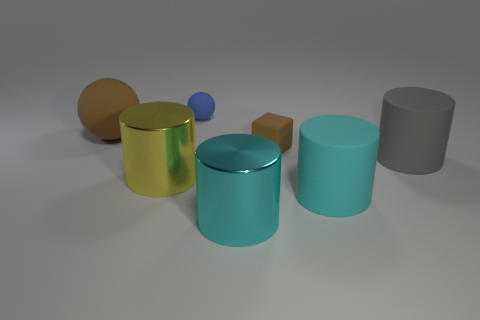Add 1 big yellow rubber objects. How many objects exist? 8 Subtract all cubes. How many objects are left? 6 Add 7 big yellow spheres. How many big yellow spheres exist? 7 Subtract 1 cyan cylinders. How many objects are left? 6 Subtract all blue matte balls. Subtract all large brown things. How many objects are left? 5 Add 2 brown rubber balls. How many brown rubber balls are left? 3 